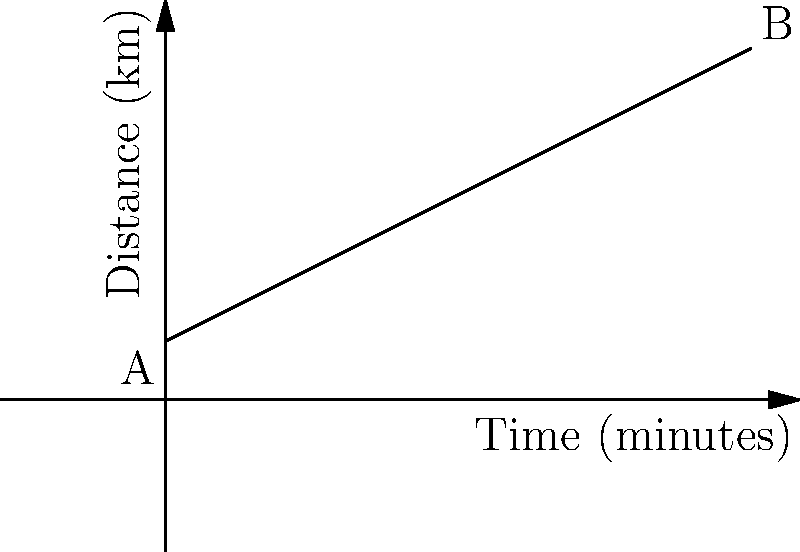You're practicing rollerblading in a straight line and tracking your progress. The graph shows your distance traveled over time. Calculate your average speed in kilometers per hour (km/h) for the entire journey from point A to point B. To find the average speed, we need to determine the total distance traveled and the total time taken. Then, we'll use the formula: Speed = Distance / Time.

Step 1: Find the total distance
- At point A (start): 1 km
- At point B (end): 6 km
- Total distance = 6 km - 1 km = 5 km

Step 2: Find the total time
- The x-axis represents time in minutes
- From A to B, the time is 10 minutes

Step 3: Calculate the speed
- Speed = Distance / Time
- Speed = 5 km / (10/60) hours (converting minutes to hours)
- Speed = 5 / (1/6) km/h
- Speed = 5 * 6 km/h = 30 km/h

Therefore, your average speed for the entire journey is 30 km/h.
Answer: 30 km/h 